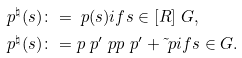Convert formula to latex. <formula><loc_0><loc_0><loc_500><loc_500>\ p ^ { \natural } ( s ) & \colon = \ p ( s ) i f s \in [ R ] \ G , \\ \ p ^ { \natural } ( s ) & \colon = p _ { \ } p ^ { \prime } \ p p _ { \ } p ^ { \prime } + \tilde { \ } p i f s \in G .</formula> 